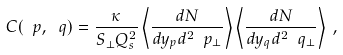<formula> <loc_0><loc_0><loc_500><loc_500>C ( \ p , \ q ) = \frac { \kappa } { S _ { \perp } Q _ { s } ^ { 2 } } \left < \frac { d N } { d y _ { p } d ^ { 2 } \ p _ { \perp } } \right > \left < \frac { d N } { d y _ { q } d ^ { 2 } \ q _ { \perp } } \right > \, ,</formula> 